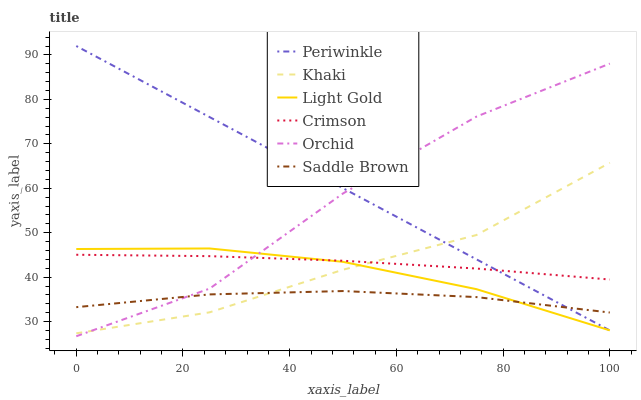Does Saddle Brown have the minimum area under the curve?
Answer yes or no. Yes. Does Periwinkle have the maximum area under the curve?
Answer yes or no. Yes. Does Crimson have the minimum area under the curve?
Answer yes or no. No. Does Crimson have the maximum area under the curve?
Answer yes or no. No. Is Periwinkle the smoothest?
Answer yes or no. Yes. Is Orchid the roughest?
Answer yes or no. Yes. Is Crimson the smoothest?
Answer yes or no. No. Is Crimson the roughest?
Answer yes or no. No. Does Orchid have the lowest value?
Answer yes or no. Yes. Does Periwinkle have the lowest value?
Answer yes or no. No. Does Periwinkle have the highest value?
Answer yes or no. Yes. Does Crimson have the highest value?
Answer yes or no. No. Is Saddle Brown less than Crimson?
Answer yes or no. Yes. Is Crimson greater than Saddle Brown?
Answer yes or no. Yes. Does Khaki intersect Light Gold?
Answer yes or no. Yes. Is Khaki less than Light Gold?
Answer yes or no. No. Is Khaki greater than Light Gold?
Answer yes or no. No. Does Saddle Brown intersect Crimson?
Answer yes or no. No. 